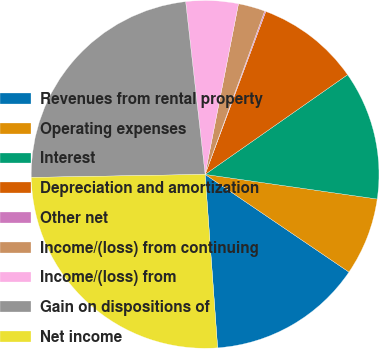Convert chart. <chart><loc_0><loc_0><loc_500><loc_500><pie_chart><fcel>Revenues from rental property<fcel>Operating expenses<fcel>Interest<fcel>Depreciation and amortization<fcel>Other net<fcel>Income/(loss) from continuing<fcel>Income/(loss) from<fcel>Gain on dispositions of<fcel>Net income<nl><fcel>14.36%<fcel>7.23%<fcel>11.98%<fcel>9.61%<fcel>0.11%<fcel>2.49%<fcel>4.86%<fcel>23.49%<fcel>25.87%<nl></chart> 